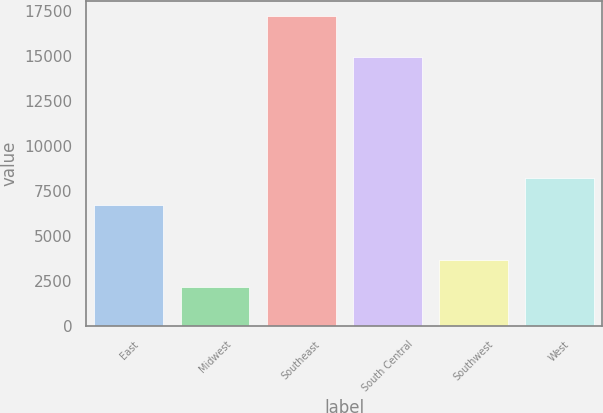<chart> <loc_0><loc_0><loc_500><loc_500><bar_chart><fcel>East<fcel>Midwest<fcel>Southeast<fcel>South Central<fcel>Southwest<fcel>West<nl><fcel>6697<fcel>2186<fcel>17216<fcel>14940<fcel>3689<fcel>8200<nl></chart> 